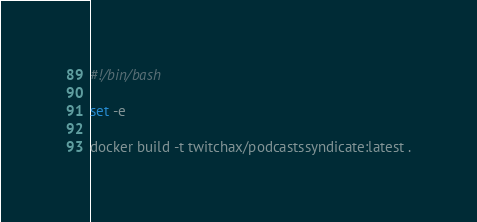Convert code to text. <code><loc_0><loc_0><loc_500><loc_500><_Bash_>#!/bin/bash

set -e

docker build -t twitchax/podcastssyndicate:latest .

</code> 